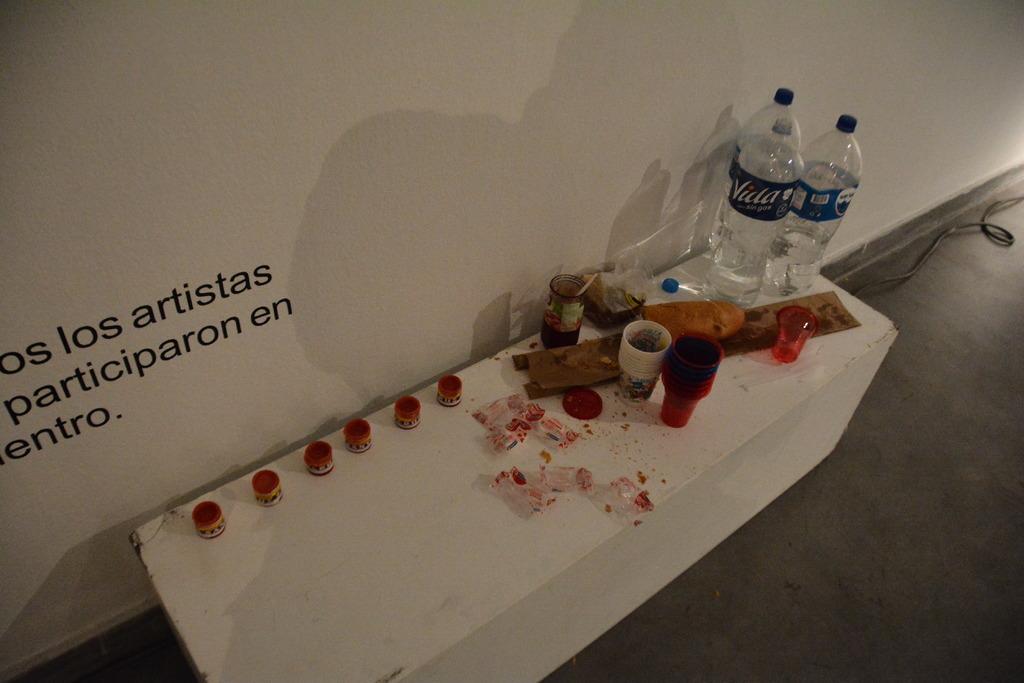What water is that?
Ensure brevity in your answer.  Vida. Is this at a restaurant?
Your response must be concise. Unanswerable. 